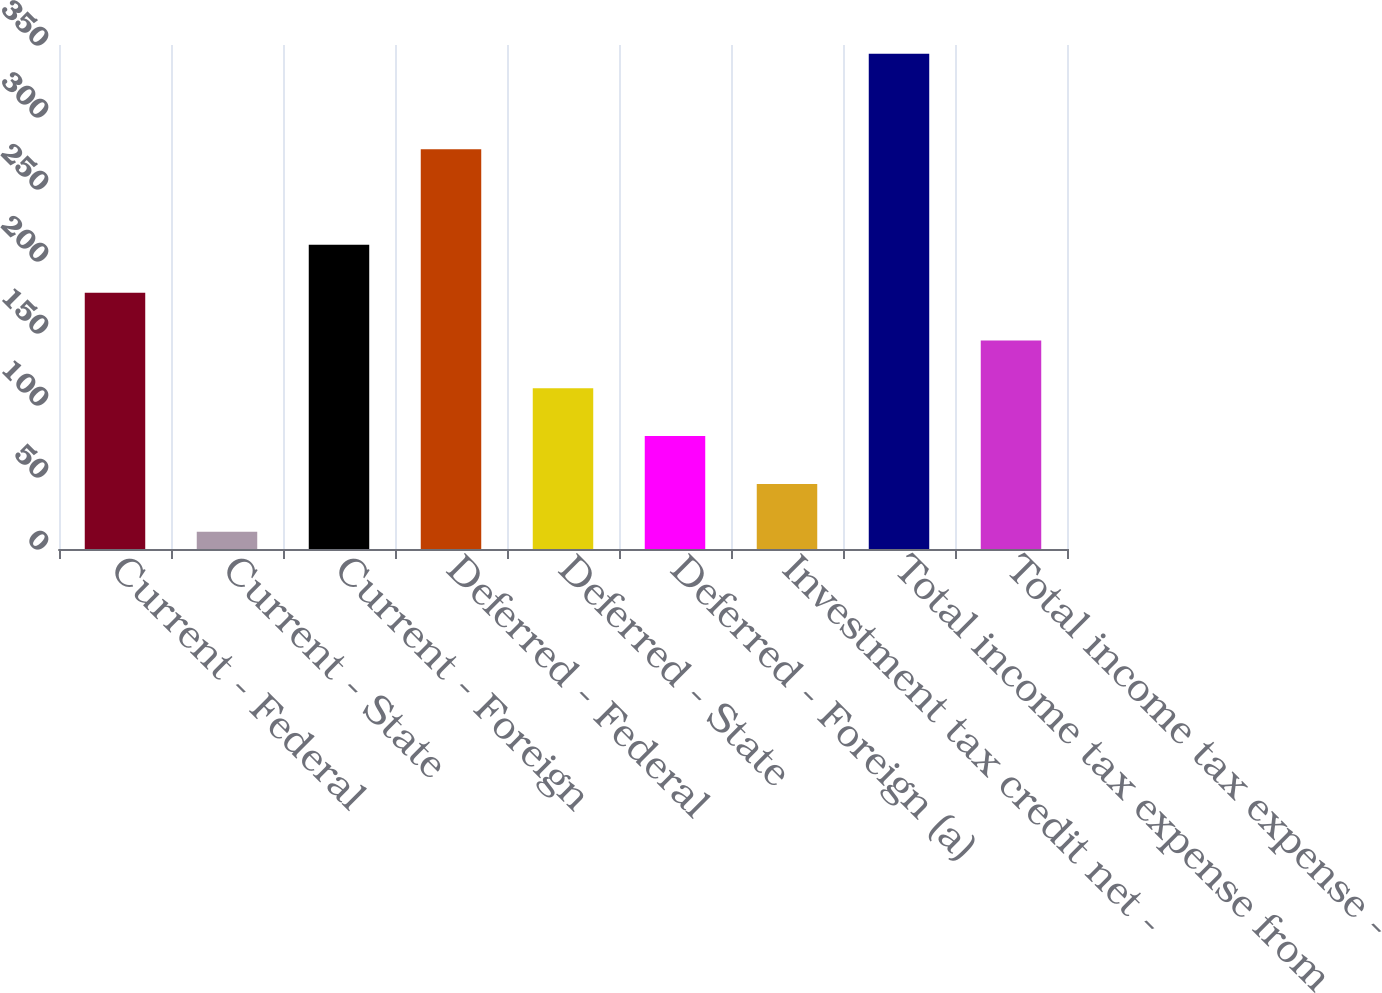<chart> <loc_0><loc_0><loc_500><loc_500><bar_chart><fcel>Current - Federal<fcel>Current - State<fcel>Current - Foreign<fcel>Deferred - Federal<fcel>Deferred - State<fcel>Deferred - Foreign (a)<fcel>Investment tax credit net -<fcel>Total income tax expense from<fcel>Total income tax expense -<nl><fcel>178<fcel>12<fcel>211.2<fcel>277.6<fcel>111.6<fcel>78.4<fcel>45.2<fcel>344<fcel>144.8<nl></chart> 